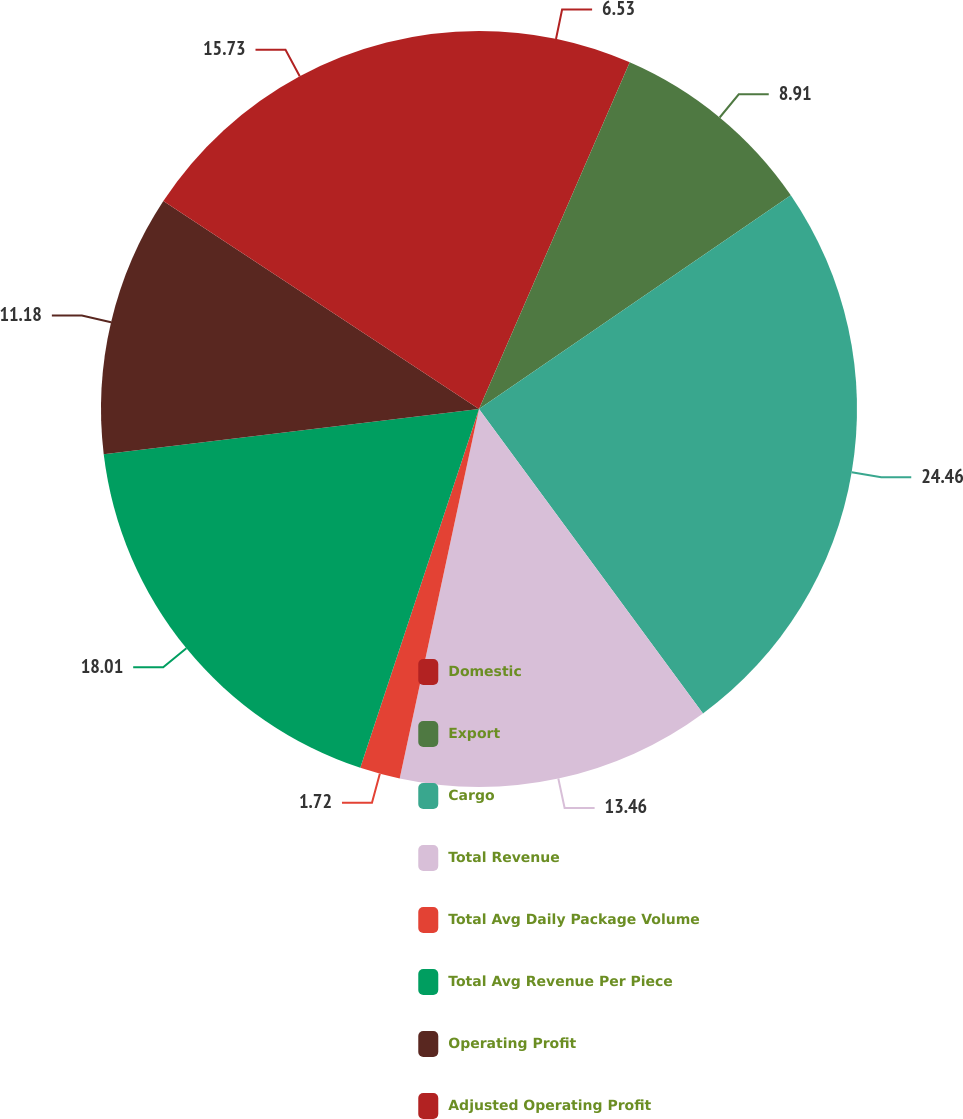<chart> <loc_0><loc_0><loc_500><loc_500><pie_chart><fcel>Domestic<fcel>Export<fcel>Cargo<fcel>Total Revenue<fcel>Total Avg Daily Package Volume<fcel>Total Avg Revenue Per Piece<fcel>Operating Profit<fcel>Adjusted Operating Profit<nl><fcel>6.53%<fcel>8.91%<fcel>24.47%<fcel>13.46%<fcel>1.72%<fcel>18.01%<fcel>11.18%<fcel>15.73%<nl></chart> 